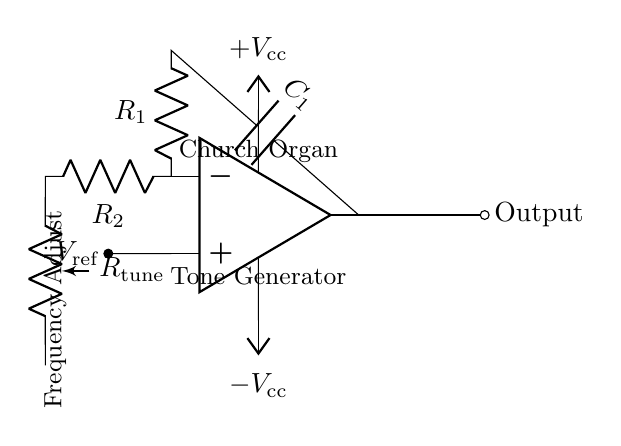What type of circuit is shown? The circuit is an oscillator circuit, specifically designed to generate musical tones. This is indicated by the presence of components such as the operational amplifier and frequency control elements.
Answer: oscillator What is the function of the operational amplifier? The operational amplifier amplifies the input signal and can be configured to produce oscillations. It plays a crucial role in determining the output frequency and waveform of the generated tones.
Answer: amplification What does the potentiometer do in this circuit? The potentiometer, labeled as R tune, adjusts the resistance in the circuit, thereby tuning the frequency of the oscillation. This variable resistance allows for fine-tuning of the musical tone produced.
Answer: frequency tuning What are the voltage levels indicated in the circuit? The circuit has a positive voltage supply labeled as V cc and a negative voltage supply labeled as negative V cc, indicating the power requirements for the operational amplifier to function correctly.
Answer: positive and negative voltages How does the capacitor influence the circuit? The capacitor, labeled as C 1, is essential for determining the timing elements of the oscillator circuit. Its charge and discharge cycles influence the oscillating frequency and are crucial for tone generation.
Answer: timing element What is the reference voltage for the operational amplifier? The reference voltage, noted as V ref, establishes a baseline for the input signal to the circuit and determines how the op-amp's output responds to the feedback from the circuit.
Answer: reference voltage How can the frequency of the generated tone be adjusted? The frequency can be adjusted by changing the resistance of the potentiometer, R tune. By altering this value, the charge and discharge times of the capacitor can be modified, thus changing the oscillation frequency.
Answer: adjust resistance 